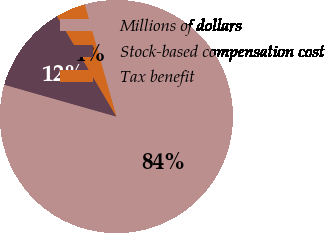Convert chart. <chart><loc_0><loc_0><loc_500><loc_500><pie_chart><fcel>Millions of dollars<fcel>Stock-based compensation cost<fcel>Tax benefit<nl><fcel>83.8%<fcel>12.09%<fcel>4.12%<nl></chart> 